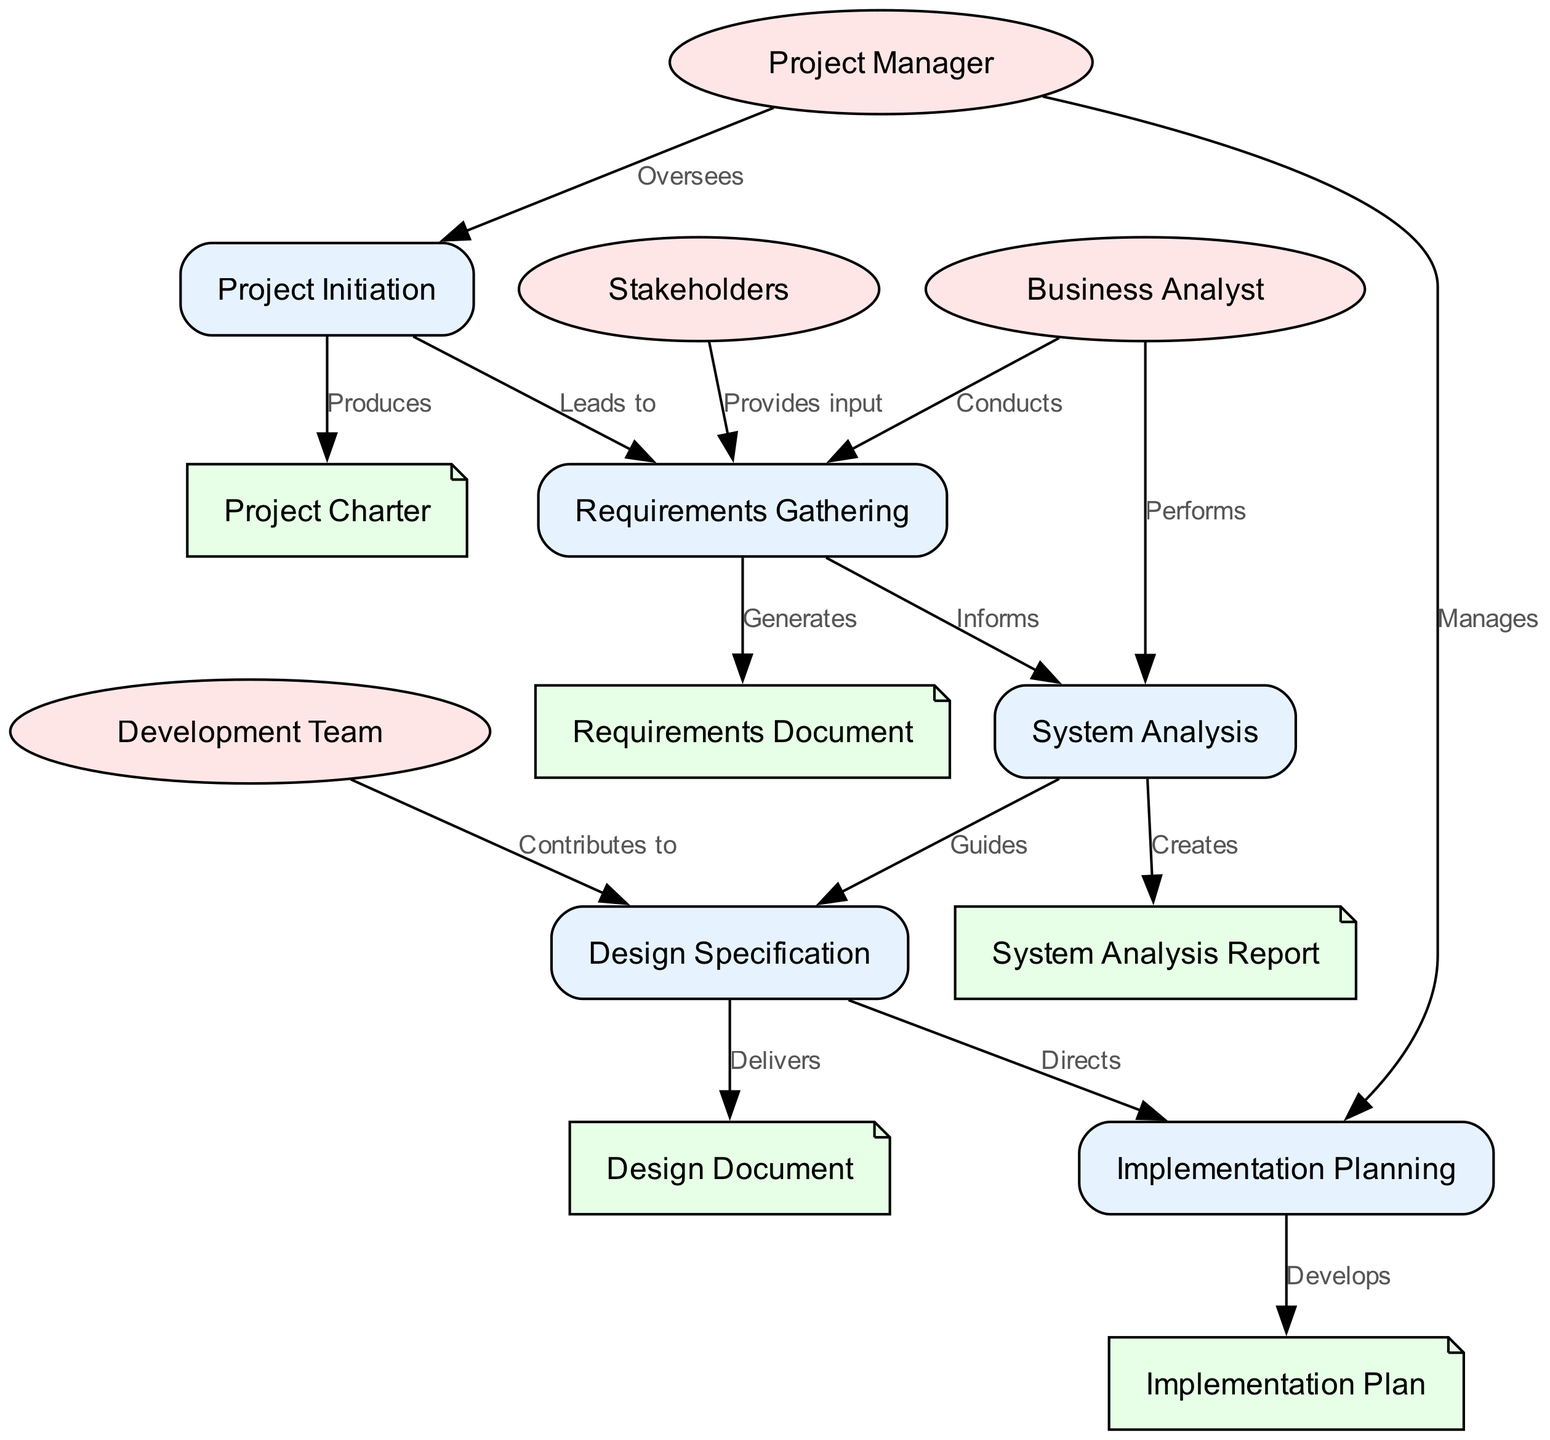What is the first step in the systems analysis process flow? The first step is "Project Initiation", as it is the first node in the diagram, indicating the starting point of the process.
Answer: Project Initiation How many stakeholders are involved in the requirements gathering phase? There are two stakeholders involved: the "Business Analyst" who conducts the gathering, and "Stakeholders" who provide input during this phase.
Answer: Two What document is generated from the requirements gathering? The document generated is the "Requirements Document", as indicated by the edge showing that the requirements gathering phase directly generates this deliverable.
Answer: Requirements Document Which phase guides the design specification? The "System Analysis" phase guides the "Design Specification", according to the labeled edge that connects these two nodes.
Answer: System Analysis Which stakeholder oversees the entire process? The "Project Manager" oversees the entire process, as shown by the edge leading from the Project Manager to the Project Initiation node.
Answer: Project Manager What is the final deliverable in the systems analysis process flow? The final deliverable is the "Implementation Plan", produced from the "Implementation Planning" phase as the last part of the flow.
Answer: Implementation Plan List the deliverables produced from each phase in the process. The deliverables are: Project Charter from Project Initiation, Requirements Document from Requirements Gathering, System Analysis Report from System Analysis, Design Document from Design Specification, and Implementation Plan from Implementation Planning.
Answer: Project Charter, Requirements Document, System Analysis Report, Design Document, Implementation Plan In the diagram, which group contributes to the design specification? The "Development Team" contributes to the "Design Specification", as indicated by the relevant edge that connects these two entities.
Answer: Development Team How do the requirements gathering and system analysis phases relate? The "Requirements Gathering" phase informs the "System Analysis" phase, as shown by the edge labeled "Informs" connecting these two phases.
Answer: Informs 